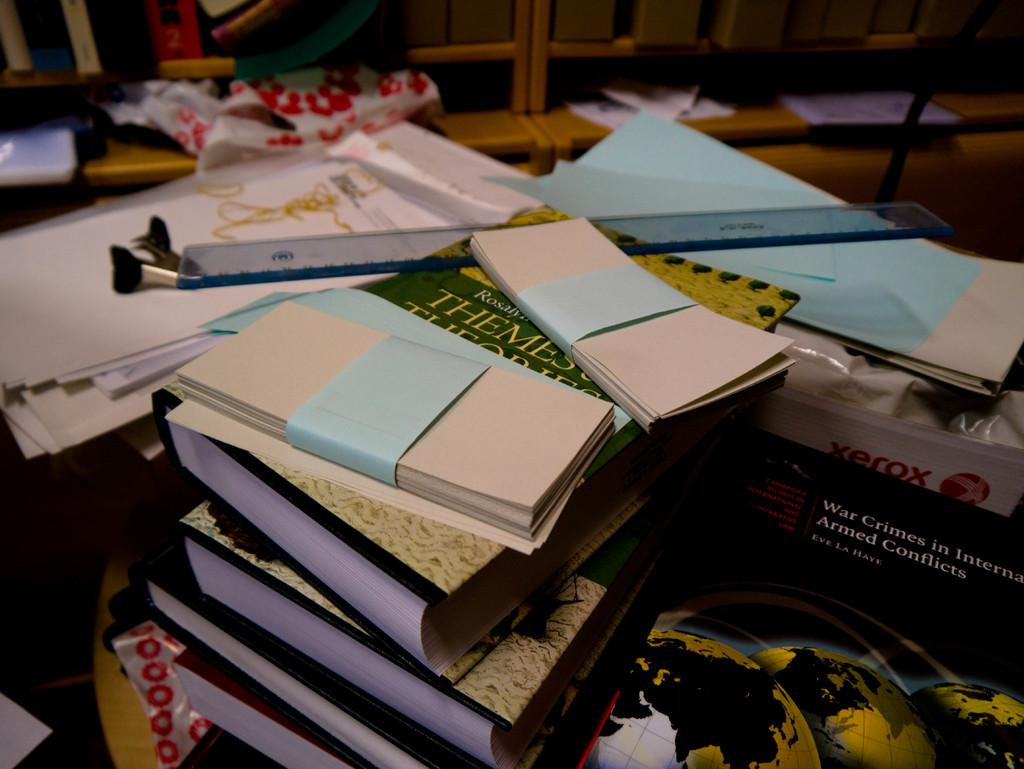Provide a one-sentence caption for the provided image. A stack of important books and papers on a table with a book called War Crimes in International Armed Conflicts holding up the stack on the right. 